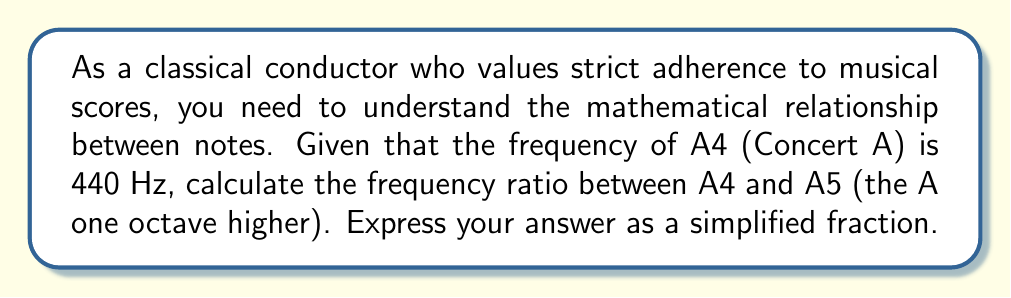Solve this math problem. To solve this problem, we need to understand the relationship between frequency and octaves in music theory:

1) In Western music, an octave represents a doubling of frequency.

2) A5 is exactly one octave higher than A4.

3) Therefore, the frequency of A5 will be twice the frequency of A4.

Let's calculate:

1) Frequency of A4 = 440 Hz

2) Frequency of A5 = 2 * 440 Hz = 880 Hz

3) The frequency ratio is expressed as:

   $$\text{Ratio} = \frac{\text{Frequency of higher note}}{\text{Frequency of lower note}} = \frac{880 \text{ Hz}}{440 \text{ Hz}}$$

4) Simplify the fraction:

   $$\frac{880}{440} = \frac{2}{1} = 2$$

Thus, the frequency ratio between A4 and A5 is 2:1, or simply 2.

This ratio is fundamental in music theory and is consistent across all octaves, regardless of the starting frequency. Understanding this precise mathematical relationship is crucial for a conductor who values strict adherence to the score, as it underlies the structure of the musical scale.
Answer: $2:1$ or $2$ 